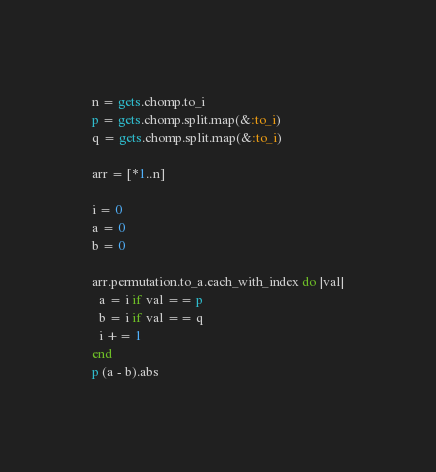Convert code to text. <code><loc_0><loc_0><loc_500><loc_500><_Ruby_>n = gets.chomp.to_i
p = gets.chomp.split.map(&:to_i)
q = gets.chomp.split.map(&:to_i)

arr = [*1..n]

i = 0
a = 0
b = 0

arr.permutation.to_a.each_with_index do |val|
  a = i if val == p
  b = i if val == q
  i += 1
end
p (a - b).abs

</code> 